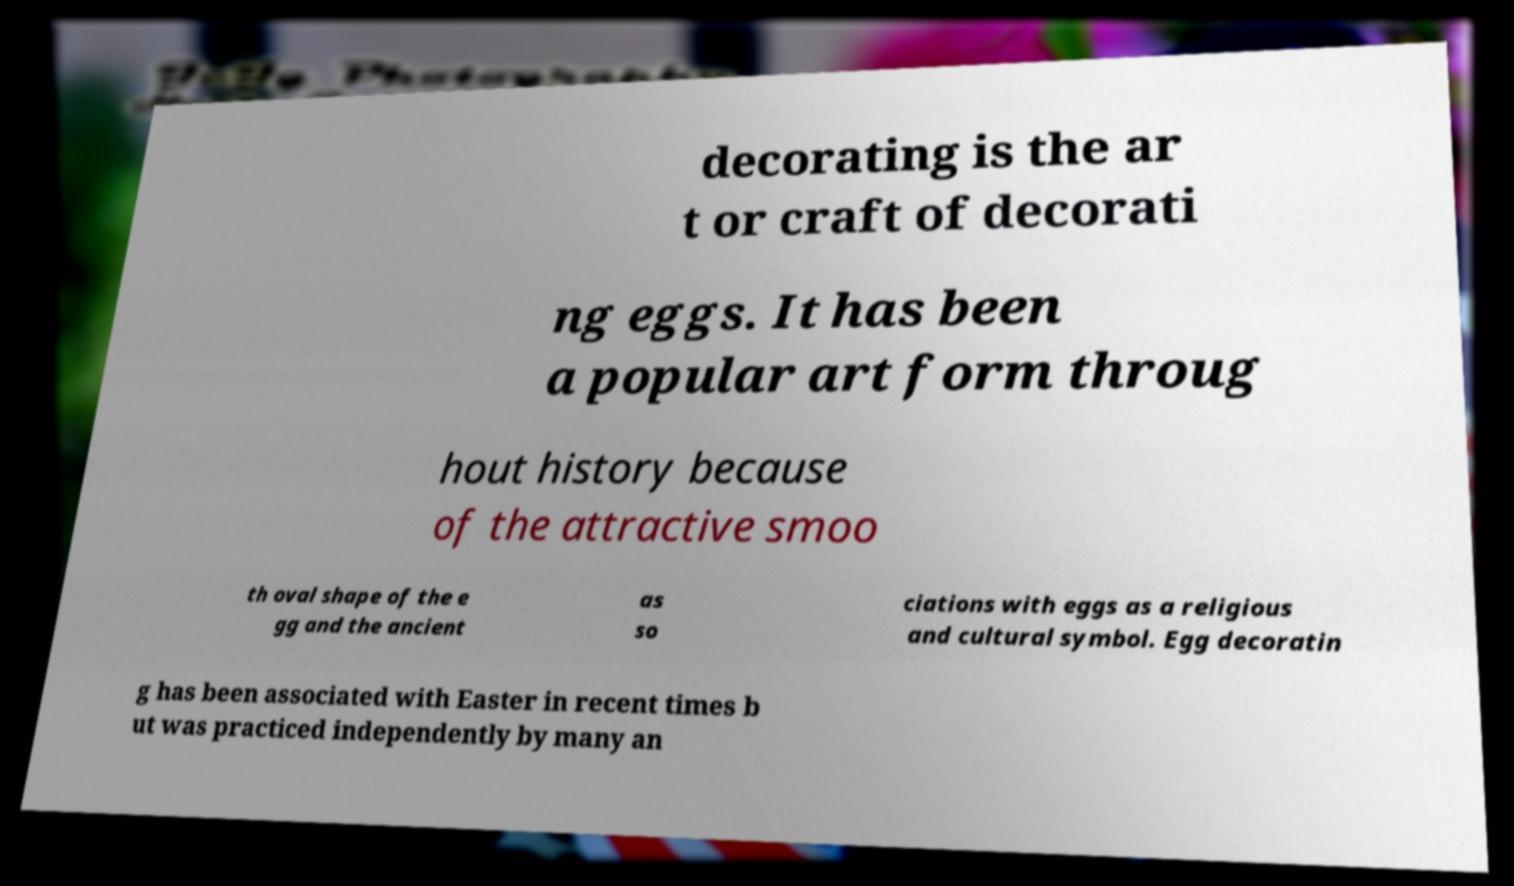Please identify and transcribe the text found in this image. decorating is the ar t or craft of decorati ng eggs. It has been a popular art form throug hout history because of the attractive smoo th oval shape of the e gg and the ancient as so ciations with eggs as a religious and cultural symbol. Egg decoratin g has been associated with Easter in recent times b ut was practiced independently by many an 